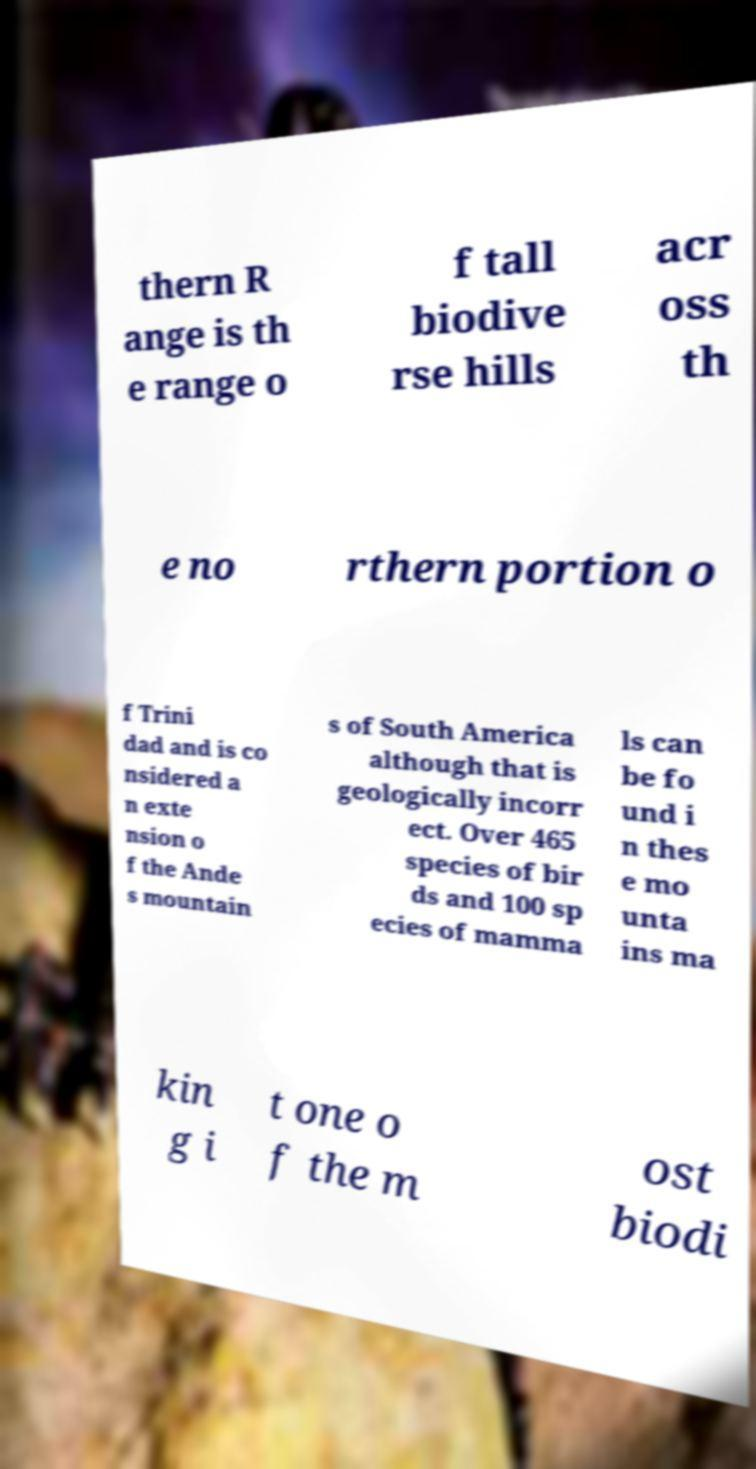For documentation purposes, I need the text within this image transcribed. Could you provide that? thern R ange is th e range o f tall biodive rse hills acr oss th e no rthern portion o f Trini dad and is co nsidered a n exte nsion o f the Ande s mountain s of South America although that is geologically incorr ect. Over 465 species of bir ds and 100 sp ecies of mamma ls can be fo und i n thes e mo unta ins ma kin g i t one o f the m ost biodi 